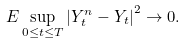Convert formula to latex. <formula><loc_0><loc_0><loc_500><loc_500>E \sup _ { 0 \leq t \leq T } \left | Y _ { t } ^ { n } - Y _ { t } \right | ^ { 2 } \rightarrow 0 .</formula> 